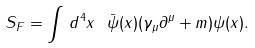Convert formula to latex. <formula><loc_0><loc_0><loc_500><loc_500>S _ { F } = \int \, d ^ { 4 } x \ \bar { \psi } ( x ) ( \gamma _ { \mu } \partial ^ { \mu } + m ) \psi ( x ) .</formula> 